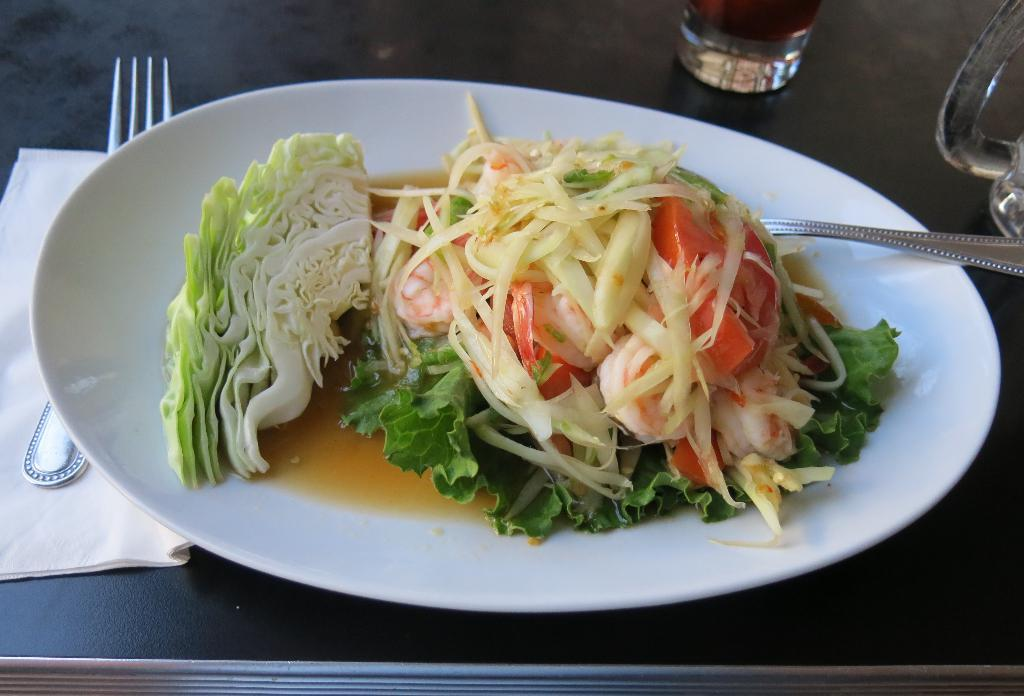What type of food is on the plate in the image? There is a vegetable salad on a plate in the image. What is beside the plate on the table? There is a glass beside the plate. What utensil is present in the image? There is a fork in the image. Where are the plate and glass located? The plate and glass are on a table. What type of ornament is hanging from the clock in the image? There is no clock or ornament present in the image. What kind of paste is being used to stick the vegetables together in the salad? There is no paste used in the salad; the vegetables are not stuck together. 